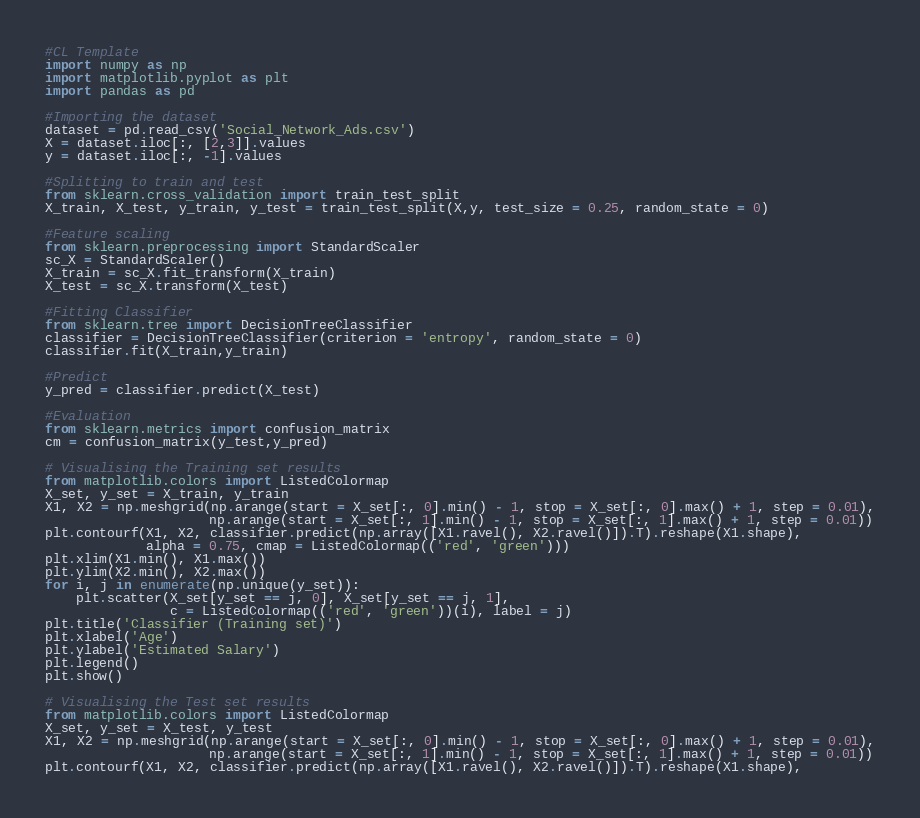<code> <loc_0><loc_0><loc_500><loc_500><_Python_>#CL Template
import numpy as np
import matplotlib.pyplot as plt
import pandas as pd

#Importing the dataset
dataset = pd.read_csv('Social_Network_Ads.csv')
X = dataset.iloc[:, [2,3]].values
y = dataset.iloc[:, -1].values

#Splitting to train and test
from sklearn.cross_validation import train_test_split
X_train, X_test, y_train, y_test = train_test_split(X,y, test_size = 0.25, random_state = 0)

#Feature scaling
from sklearn.preprocessing import StandardScaler
sc_X = StandardScaler()
X_train = sc_X.fit_transform(X_train)
X_test = sc_X.transform(X_test)

#Fitting Classifier
from sklearn.tree import DecisionTreeClassifier
classifier = DecisionTreeClassifier(criterion = 'entropy', random_state = 0)
classifier.fit(X_train,y_train)

#Predict
y_pred = classifier.predict(X_test)

#Evaluation
from sklearn.metrics import confusion_matrix
cm = confusion_matrix(y_test,y_pred)

# Visualising the Training set results
from matplotlib.colors import ListedColormap
X_set, y_set = X_train, y_train
X1, X2 = np.meshgrid(np.arange(start = X_set[:, 0].min() - 1, stop = X_set[:, 0].max() + 1, step = 0.01),
                     np.arange(start = X_set[:, 1].min() - 1, stop = X_set[:, 1].max() + 1, step = 0.01))
plt.contourf(X1, X2, classifier.predict(np.array([X1.ravel(), X2.ravel()]).T).reshape(X1.shape),
             alpha = 0.75, cmap = ListedColormap(('red', 'green')))
plt.xlim(X1.min(), X1.max())
plt.ylim(X2.min(), X2.max())
for i, j in enumerate(np.unique(y_set)):
    plt.scatter(X_set[y_set == j, 0], X_set[y_set == j, 1],
                c = ListedColormap(('red', 'green'))(i), label = j)
plt.title('Classifier (Training set)')
plt.xlabel('Age')
plt.ylabel('Estimated Salary')
plt.legend()
plt.show()

# Visualising the Test set results
from matplotlib.colors import ListedColormap
X_set, y_set = X_test, y_test
X1, X2 = np.meshgrid(np.arange(start = X_set[:, 0].min() - 1, stop = X_set[:, 0].max() + 1, step = 0.01),
                     np.arange(start = X_set[:, 1].min() - 1, stop = X_set[:, 1].max() + 1, step = 0.01))
plt.contourf(X1, X2, classifier.predict(np.array([X1.ravel(), X2.ravel()]).T).reshape(X1.shape),</code> 